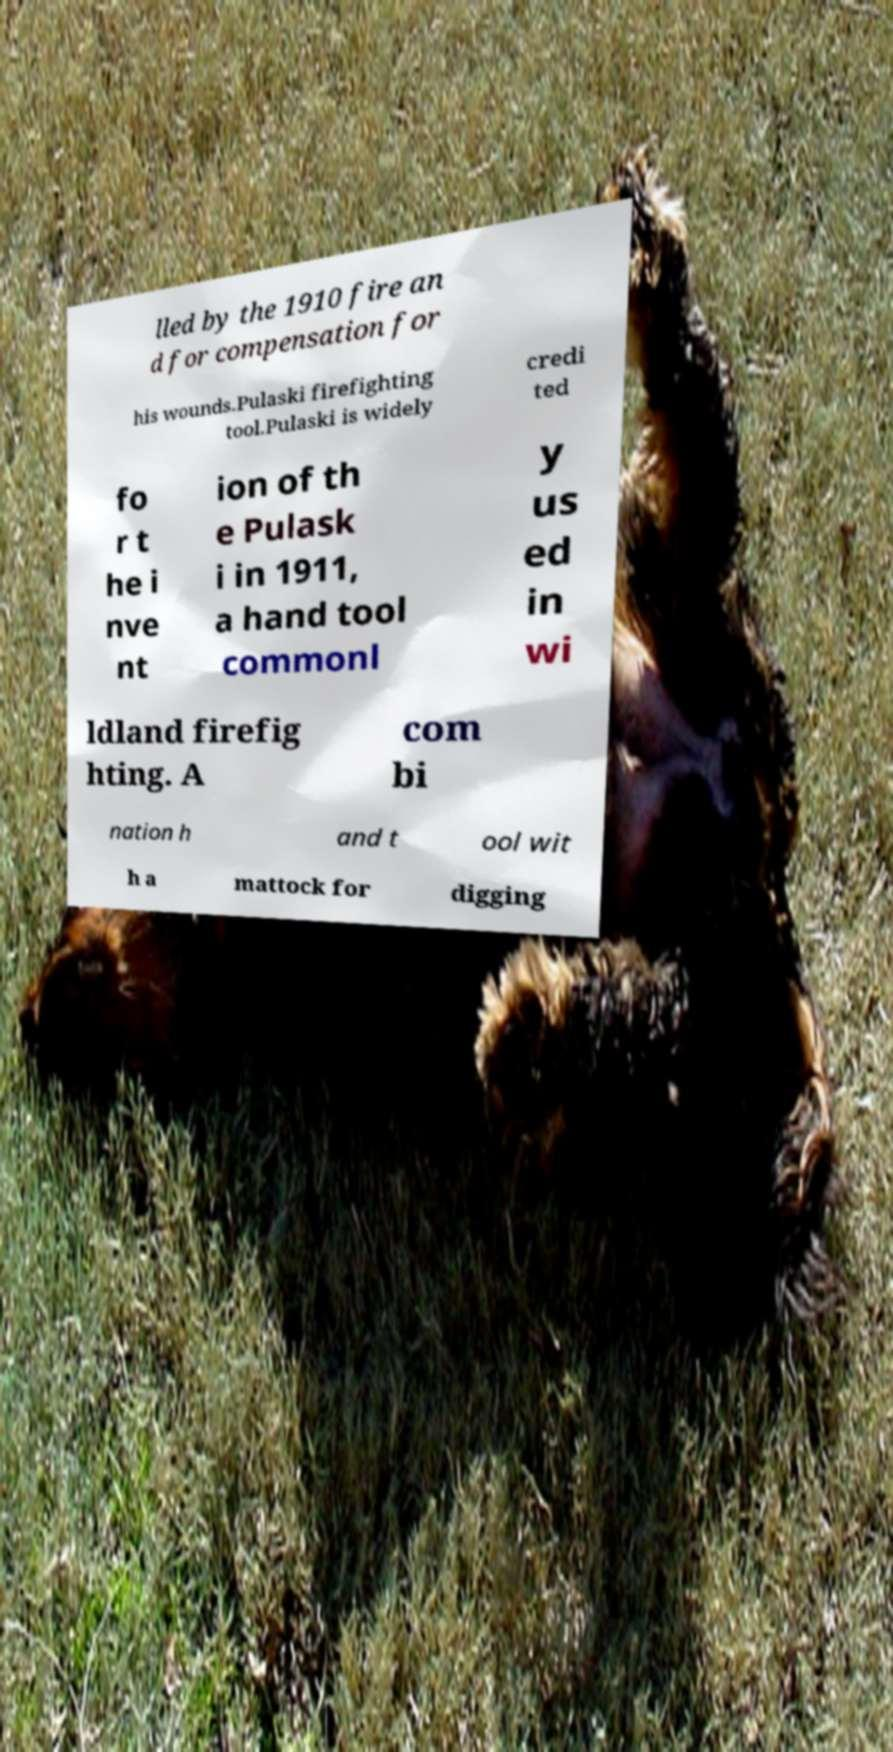Can you read and provide the text displayed in the image?This photo seems to have some interesting text. Can you extract and type it out for me? lled by the 1910 fire an d for compensation for his wounds.Pulaski firefighting tool.Pulaski is widely credi ted fo r t he i nve nt ion of th e Pulask i in 1911, a hand tool commonl y us ed in wi ldland firefig hting. A com bi nation h and t ool wit h a mattock for digging 